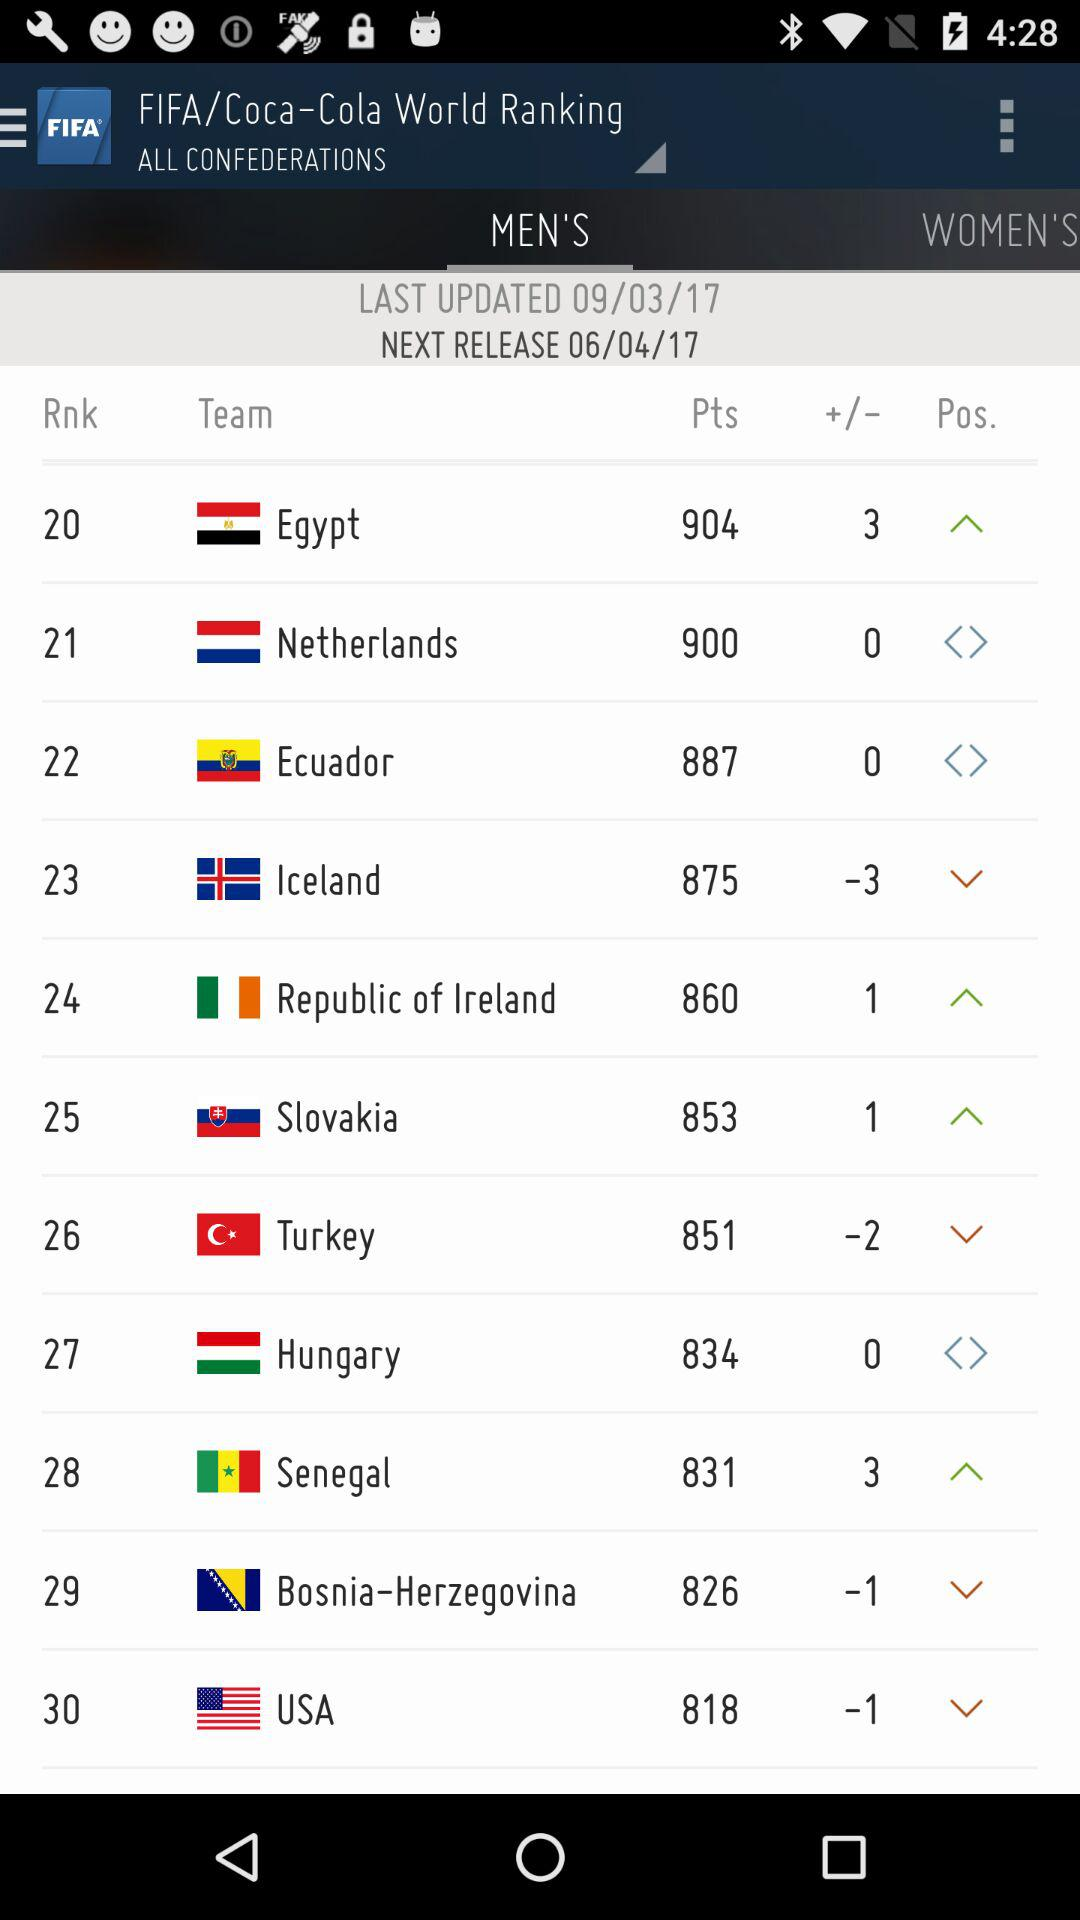What is the date of the last update? The date is September 03, 2017. 